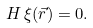<formula> <loc_0><loc_0><loc_500><loc_500>H \, \xi ( \vec { r } ) = 0 .</formula> 